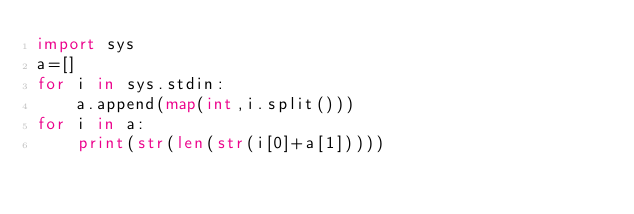Convert code to text. <code><loc_0><loc_0><loc_500><loc_500><_Python_>import sys
a=[]
for i in sys.stdin:
    a.append(map(int,i.split()))
for i in a:
    print(str(len(str(i[0]+a[1]))))</code> 